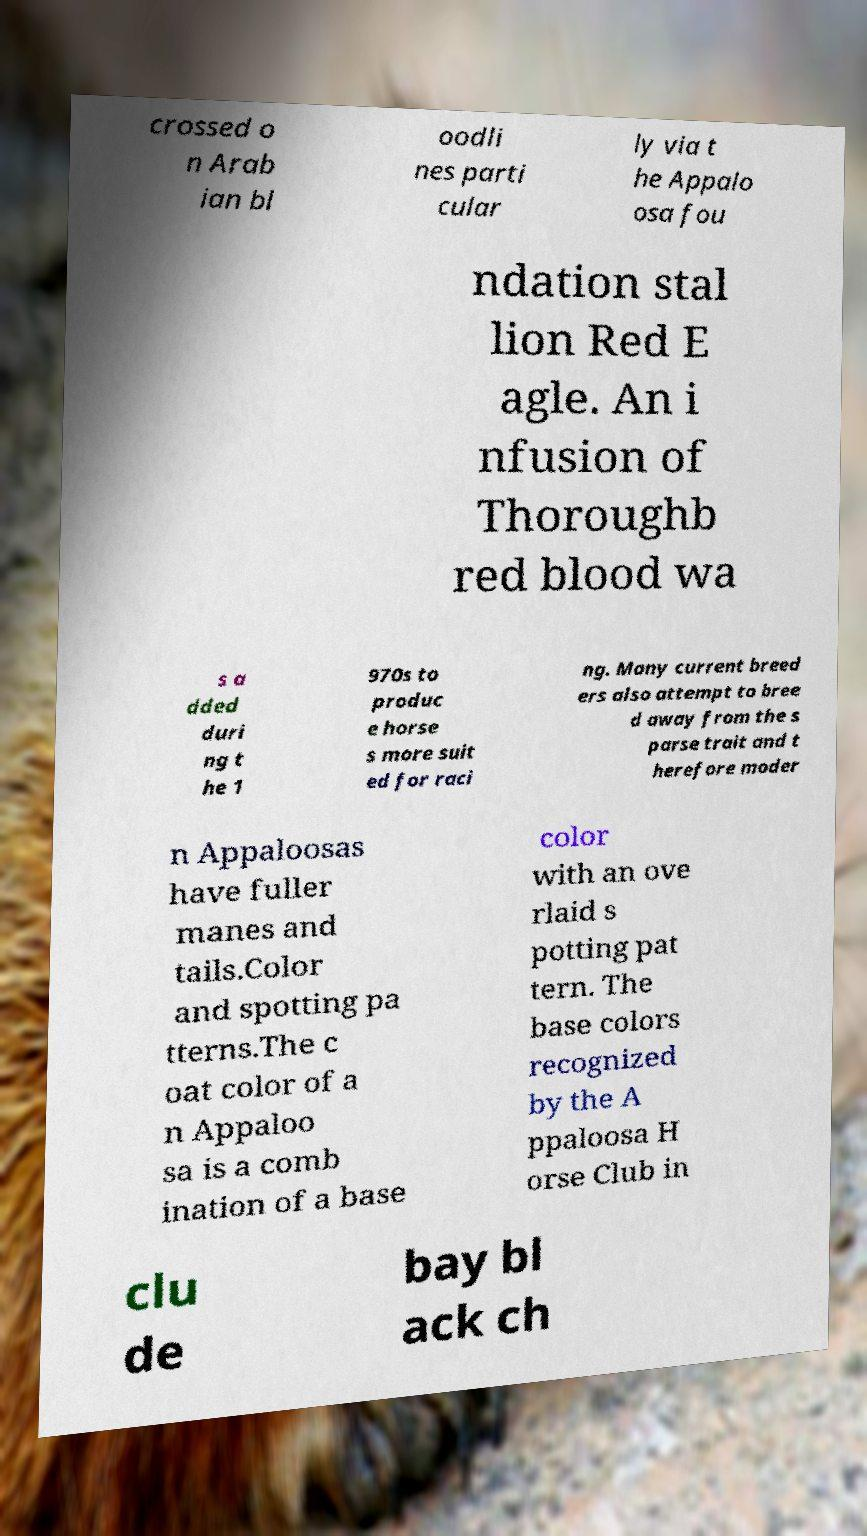Please read and relay the text visible in this image. What does it say? crossed o n Arab ian bl oodli nes parti cular ly via t he Appalo osa fou ndation stal lion Red E agle. An i nfusion of Thoroughb red blood wa s a dded duri ng t he 1 970s to produc e horse s more suit ed for raci ng. Many current breed ers also attempt to bree d away from the s parse trait and t herefore moder n Appaloosas have fuller manes and tails.Color and spotting pa tterns.The c oat color of a n Appaloo sa is a comb ination of a base color with an ove rlaid s potting pat tern. The base colors recognized by the A ppaloosa H orse Club in clu de bay bl ack ch 